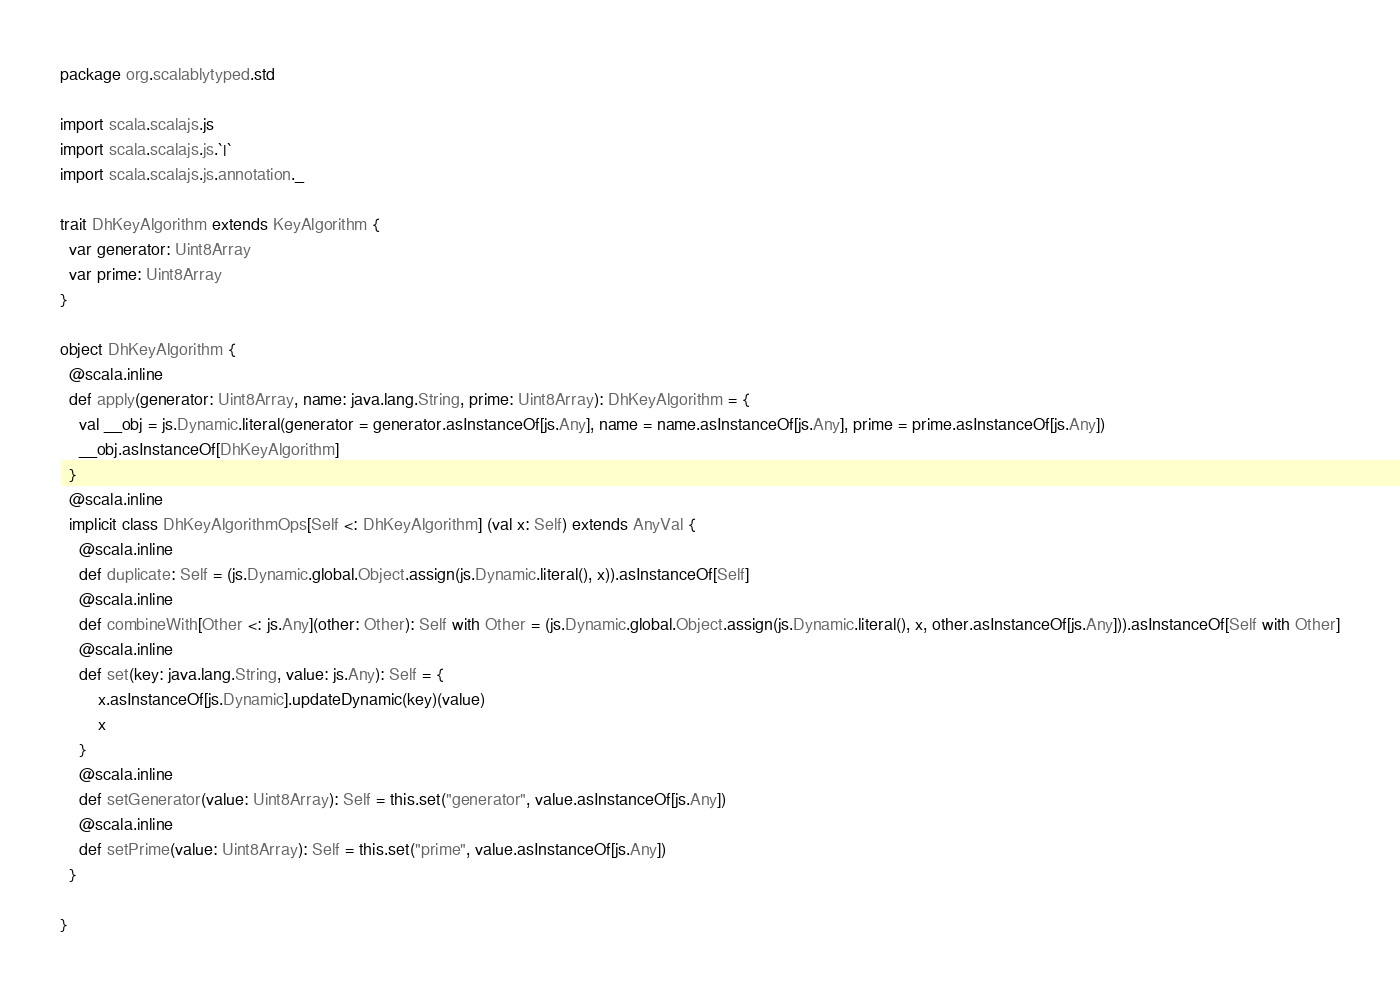Convert code to text. <code><loc_0><loc_0><loc_500><loc_500><_Scala_>package org.scalablytyped.std

import scala.scalajs.js
import scala.scalajs.js.`|`
import scala.scalajs.js.annotation._

trait DhKeyAlgorithm extends KeyAlgorithm {
  var generator: Uint8Array
  var prime: Uint8Array
}

object DhKeyAlgorithm {
  @scala.inline
  def apply(generator: Uint8Array, name: java.lang.String, prime: Uint8Array): DhKeyAlgorithm = {
    val __obj = js.Dynamic.literal(generator = generator.asInstanceOf[js.Any], name = name.asInstanceOf[js.Any], prime = prime.asInstanceOf[js.Any])
    __obj.asInstanceOf[DhKeyAlgorithm]
  }
  @scala.inline
  implicit class DhKeyAlgorithmOps[Self <: DhKeyAlgorithm] (val x: Self) extends AnyVal {
    @scala.inline
    def duplicate: Self = (js.Dynamic.global.Object.assign(js.Dynamic.literal(), x)).asInstanceOf[Self]
    @scala.inline
    def combineWith[Other <: js.Any](other: Other): Self with Other = (js.Dynamic.global.Object.assign(js.Dynamic.literal(), x, other.asInstanceOf[js.Any])).asInstanceOf[Self with Other]
    @scala.inline
    def set(key: java.lang.String, value: js.Any): Self = {
        x.asInstanceOf[js.Dynamic].updateDynamic(key)(value)
        x
    }
    @scala.inline
    def setGenerator(value: Uint8Array): Self = this.set("generator", value.asInstanceOf[js.Any])
    @scala.inline
    def setPrime(value: Uint8Array): Self = this.set("prime", value.asInstanceOf[js.Any])
  }
  
}

</code> 